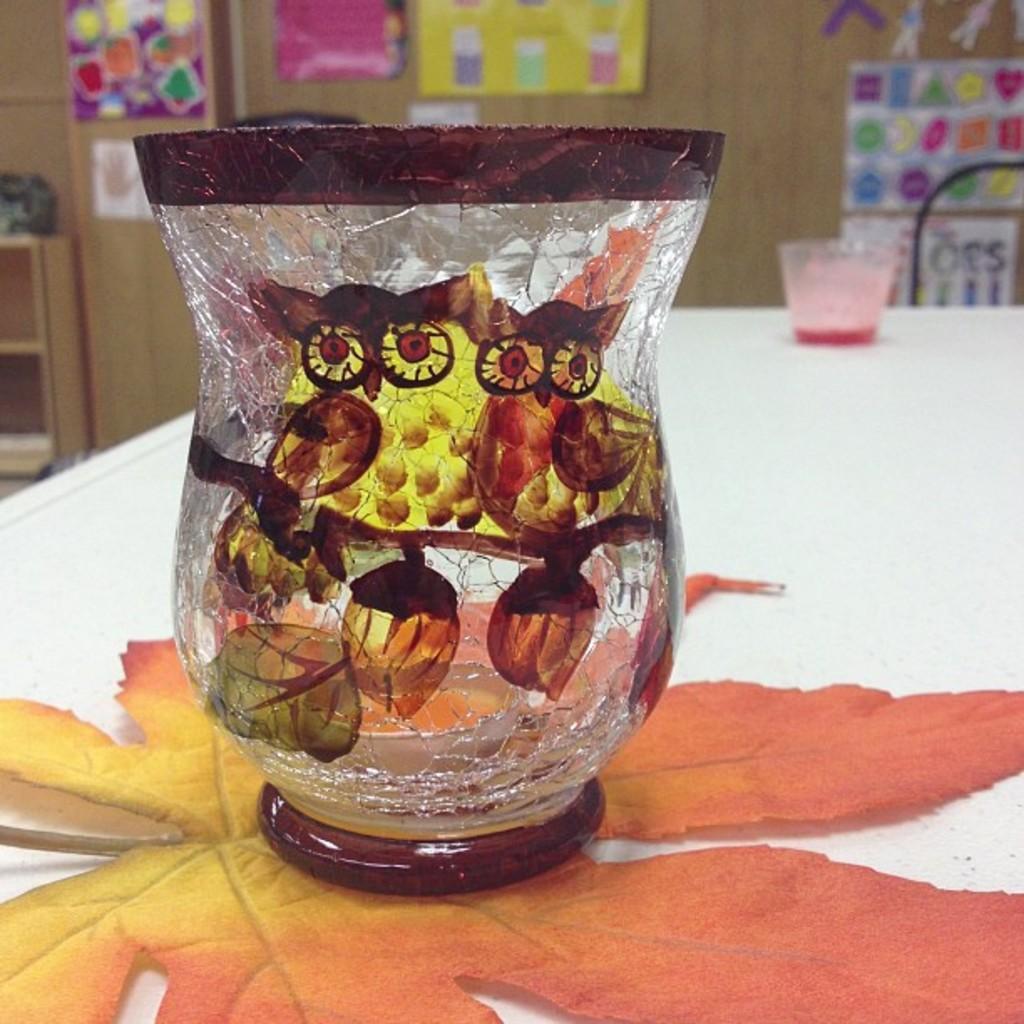Could you give a brief overview of what you see in this image? In this picture I can see couple of bowls and I can see painting on the bowl and a leaf on the table and I can see few posts on the wall and looks like shelves on the left side of the picture. 